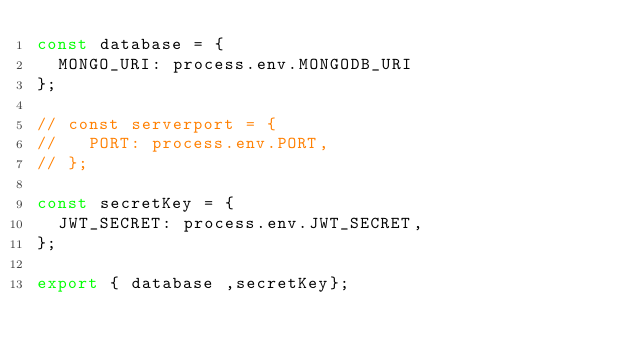<code> <loc_0><loc_0><loc_500><loc_500><_JavaScript_>const database = {
  MONGO_URI: process.env.MONGODB_URI
};

// const serverport = {
//   PORT: process.env.PORT,
// };

const secretKey = {
  JWT_SECRET: process.env.JWT_SECRET,
};

export { database ,secretKey};</code> 